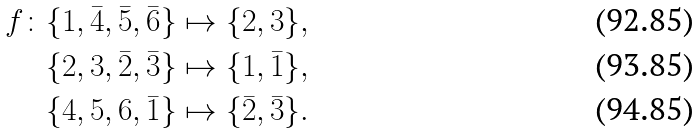Convert formula to latex. <formula><loc_0><loc_0><loc_500><loc_500>f \colon \{ 1 , \bar { 4 } , \bar { 5 } , \bar { 6 } \} & \mapsto \{ 2 , 3 \} , \\ \{ 2 , 3 , \bar { 2 } , \bar { 3 } \} & \mapsto \{ 1 , \bar { 1 } \} , \\ \{ 4 , 5 , 6 , \bar { 1 } \} & \mapsto \{ \bar { 2 } , \bar { 3 } \} .</formula> 